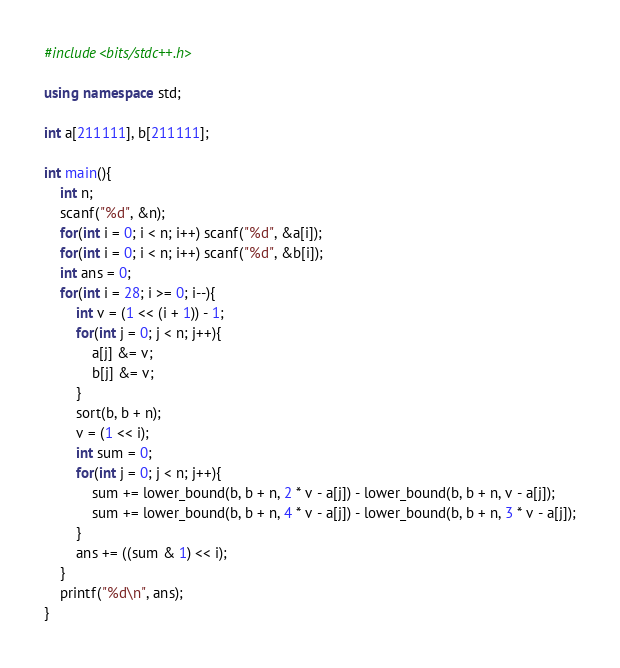Convert code to text. <code><loc_0><loc_0><loc_500><loc_500><_C++_>#include<bits/stdc++.h>

using namespace std;

int a[211111], b[211111];

int main(){
    int n;
    scanf("%d", &n);
    for(int i = 0; i < n; i++) scanf("%d", &a[i]);
    for(int i = 0; i < n; i++) scanf("%d", &b[i]);
    int ans = 0;
    for(int i = 28; i >= 0; i--){
        int v = (1 << (i + 1)) - 1;
        for(int j = 0; j < n; j++){
            a[j] &= v;
            b[j] &= v;
        }
        sort(b, b + n);
        v = (1 << i);
        int sum = 0;
        for(int j = 0; j < n; j++){
            sum += lower_bound(b, b + n, 2 * v - a[j]) - lower_bound(b, b + n, v - a[j]);
            sum += lower_bound(b, b + n, 4 * v - a[j]) - lower_bound(b, b + n, 3 * v - a[j]);
        }
        ans += ((sum & 1) << i);
    }
    printf("%d\n", ans);
}</code> 